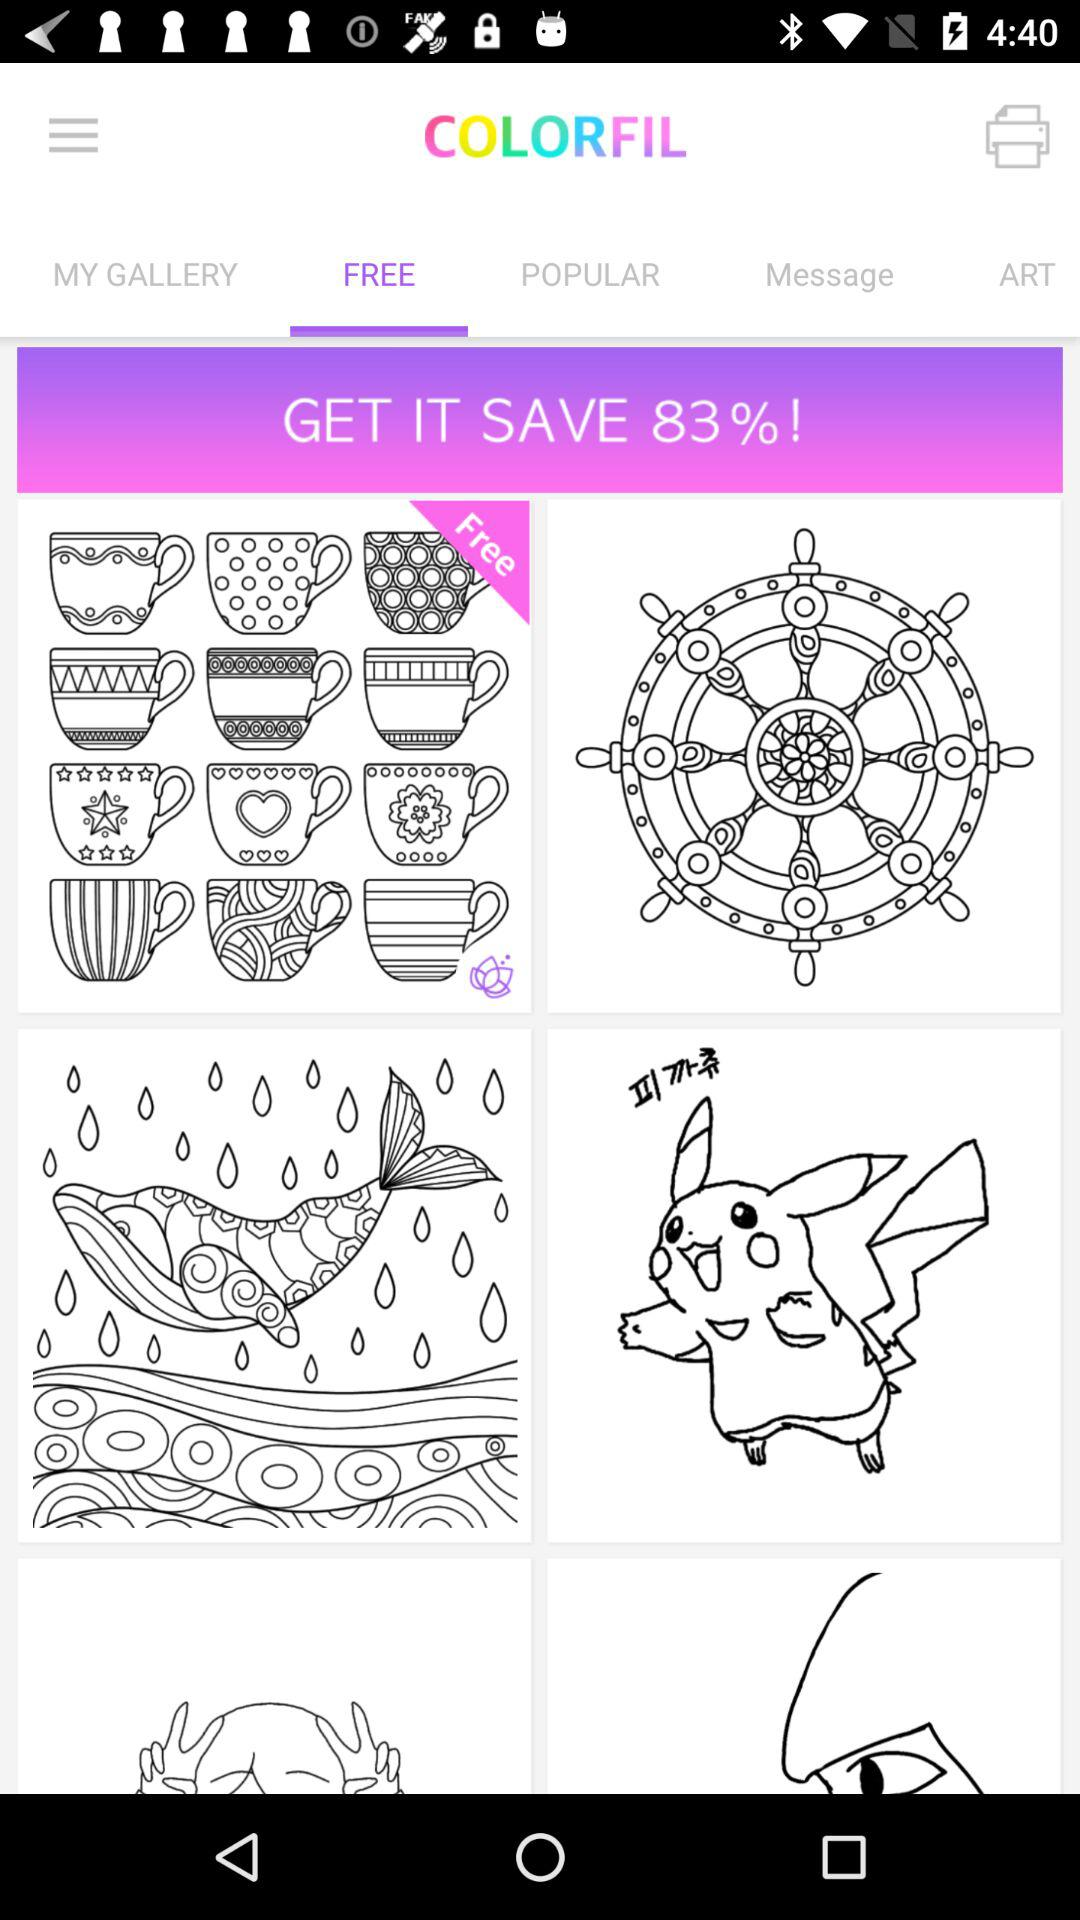What is the application name? The application name is "COLORFIL". 